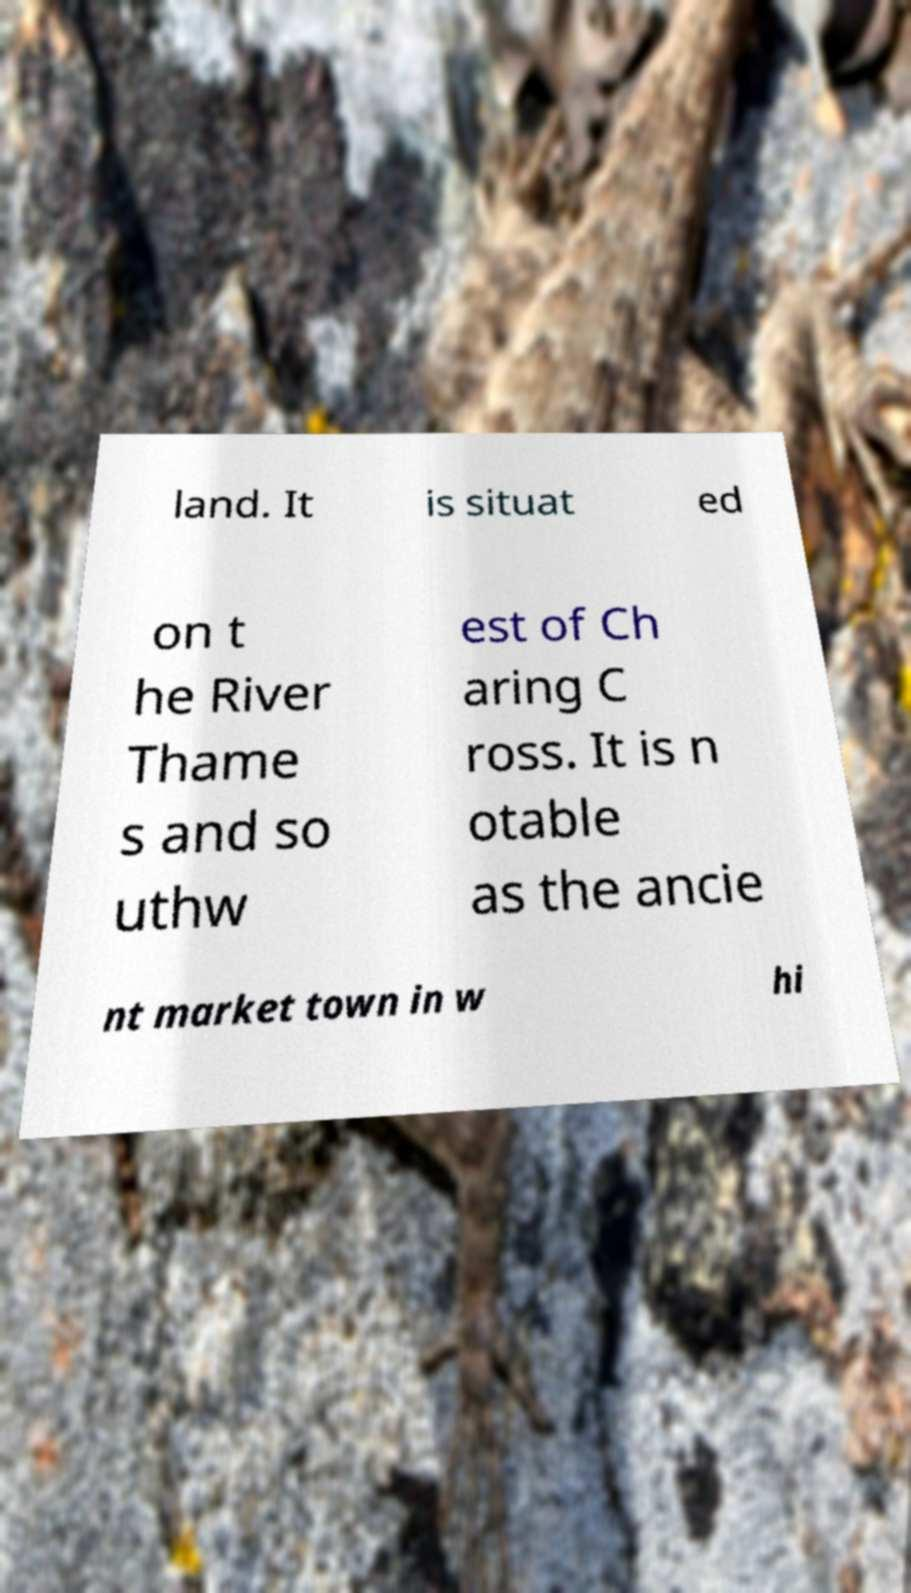Can you read and provide the text displayed in the image?This photo seems to have some interesting text. Can you extract and type it out for me? land. It is situat ed on t he River Thame s and so uthw est of Ch aring C ross. It is n otable as the ancie nt market town in w hi 